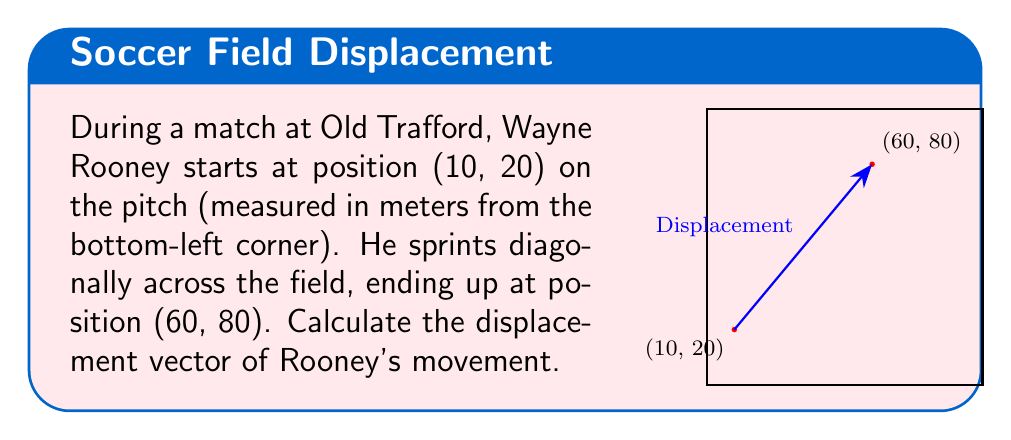Solve this math problem. To compute the displacement vector, we need to follow these steps:

1) The displacement vector is the difference between the final position and the initial position.

2) Let's define the initial position as $\vec{r}_i = (10, 20)$ and the final position as $\vec{r}_f = (60, 80)$.

3) The displacement vector $\vec{d}$ is given by:

   $$\vec{d} = \vec{r}_f - \vec{r}_i$$

4) Subtracting the coordinates:

   $$\vec{d} = (60, 80) - (10, 20)$$

5) Perform the vector subtraction:

   $$\vec{d} = (60 - 10, 80 - 20)$$

6) Simplify:

   $$\vec{d} = (50, 60)$$

Thus, Rooney's displacement vector is (50, 60) meters.
Answer: $\vec{d} = (50, 60)$ meters 